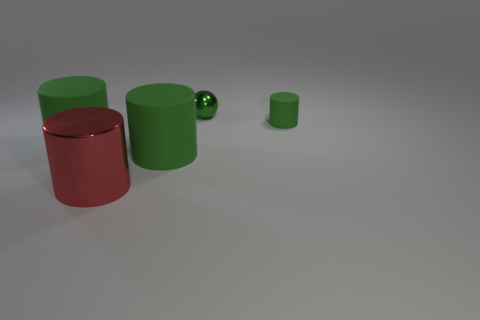Subtract all yellow cubes. How many green cylinders are left? 3 Subtract all small cylinders. How many cylinders are left? 3 Add 5 big gray shiny cylinders. How many objects exist? 10 Subtract all purple cylinders. Subtract all blue cubes. How many cylinders are left? 4 Subtract all cylinders. How many objects are left? 1 Subtract 0 cyan cylinders. How many objects are left? 5 Subtract all big brown rubber balls. Subtract all small green things. How many objects are left? 3 Add 4 metallic objects. How many metallic objects are left? 6 Add 1 big gray spheres. How many big gray spheres exist? 1 